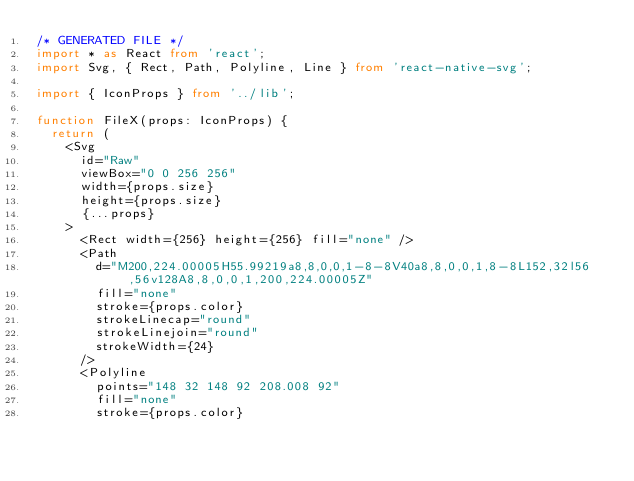<code> <loc_0><loc_0><loc_500><loc_500><_TypeScript_>/* GENERATED FILE */
import * as React from 'react';
import Svg, { Rect, Path, Polyline, Line } from 'react-native-svg';

import { IconProps } from '../lib';

function FileX(props: IconProps) {
  return (
    <Svg
      id="Raw"
      viewBox="0 0 256 256"
      width={props.size}
      height={props.size}
      {...props}
    >
      <Rect width={256} height={256} fill="none" />
      <Path
        d="M200,224.00005H55.99219a8,8,0,0,1-8-8V40a8,8,0,0,1,8-8L152,32l56,56v128A8,8,0,0,1,200,224.00005Z"
        fill="none"
        stroke={props.color}
        strokeLinecap="round"
        strokeLinejoin="round"
        strokeWidth={24}
      />
      <Polyline
        points="148 32 148 92 208.008 92"
        fill="none"
        stroke={props.color}</code> 